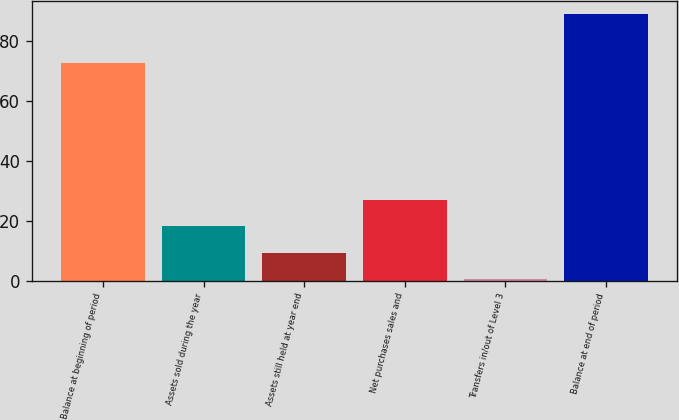<chart> <loc_0><loc_0><loc_500><loc_500><bar_chart><fcel>Balance at beginning of period<fcel>Assets sold during the year<fcel>Assets still held at year end<fcel>Net purchases sales and<fcel>Transfers in/out of Level 3<fcel>Balance at end of period<nl><fcel>72.5<fcel>18.1<fcel>9.25<fcel>26.95<fcel>0.4<fcel>88.9<nl></chart> 